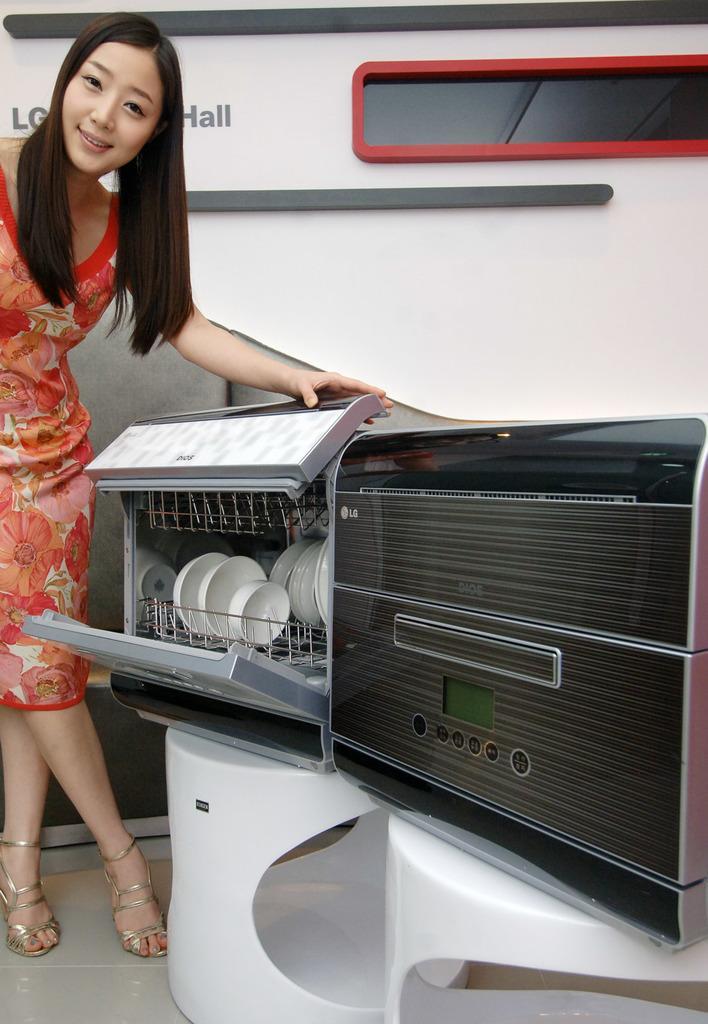Could you give a brief overview of what you see in this image? In this image we can see one woman stand and holding an object. There are two small white tables with two dish machines, there are some bowls and plates in one machine. Some text on the background white wall and one glass window. 